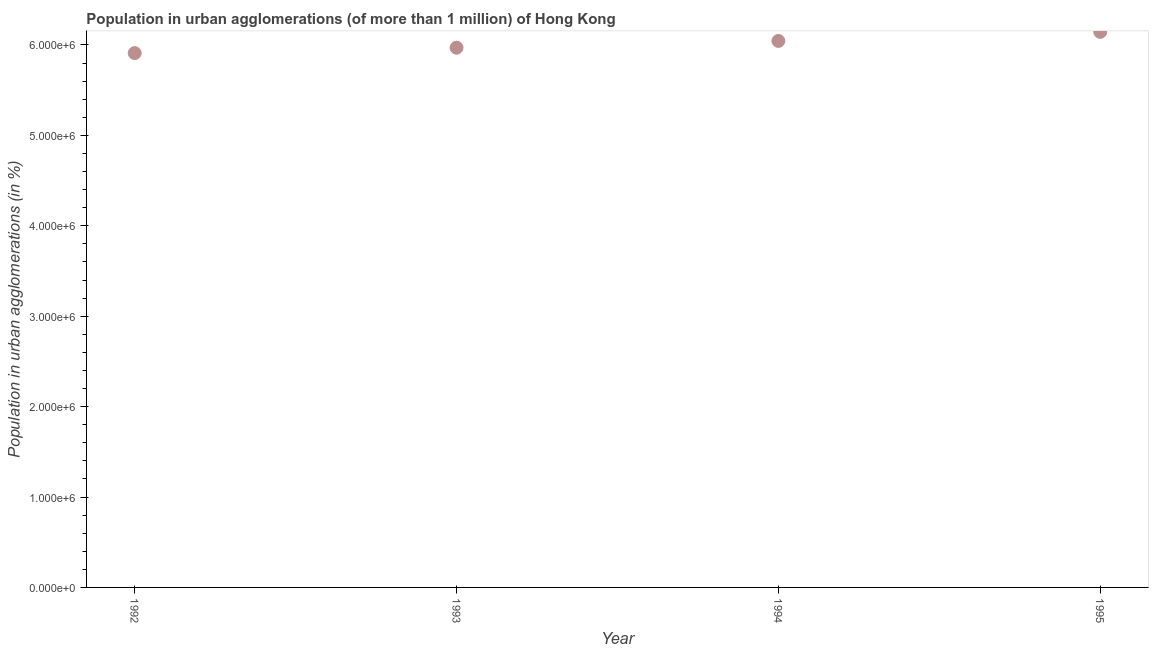What is the population in urban agglomerations in 1992?
Offer a terse response. 5.91e+06. Across all years, what is the maximum population in urban agglomerations?
Provide a short and direct response. 6.14e+06. Across all years, what is the minimum population in urban agglomerations?
Make the answer very short. 5.91e+06. In which year was the population in urban agglomerations minimum?
Offer a very short reply. 1992. What is the sum of the population in urban agglomerations?
Provide a short and direct response. 2.41e+07. What is the difference between the population in urban agglomerations in 1992 and 1993?
Make the answer very short. -5.96e+04. What is the average population in urban agglomerations per year?
Your answer should be compact. 6.02e+06. What is the median population in urban agglomerations?
Provide a succinct answer. 6.01e+06. What is the ratio of the population in urban agglomerations in 1993 to that in 1995?
Give a very brief answer. 0.97. Is the difference between the population in urban agglomerations in 1992 and 1995 greater than the difference between any two years?
Provide a short and direct response. Yes. What is the difference between the highest and the second highest population in urban agglomerations?
Offer a very short reply. 1.00e+05. Is the sum of the population in urban agglomerations in 1992 and 1995 greater than the maximum population in urban agglomerations across all years?
Offer a terse response. Yes. What is the difference between the highest and the lowest population in urban agglomerations?
Provide a short and direct response. 2.35e+05. What is the difference between two consecutive major ticks on the Y-axis?
Provide a succinct answer. 1.00e+06. What is the title of the graph?
Keep it short and to the point. Population in urban agglomerations (of more than 1 million) of Hong Kong. What is the label or title of the Y-axis?
Your response must be concise. Population in urban agglomerations (in %). What is the Population in urban agglomerations (in %) in 1992?
Your answer should be compact. 5.91e+06. What is the Population in urban agglomerations (in %) in 1993?
Offer a very short reply. 5.97e+06. What is the Population in urban agglomerations (in %) in 1994?
Offer a very short reply. 6.04e+06. What is the Population in urban agglomerations (in %) in 1995?
Your response must be concise. 6.14e+06. What is the difference between the Population in urban agglomerations (in %) in 1992 and 1993?
Provide a succinct answer. -5.96e+04. What is the difference between the Population in urban agglomerations (in %) in 1992 and 1994?
Your answer should be compact. -1.35e+05. What is the difference between the Population in urban agglomerations (in %) in 1992 and 1995?
Keep it short and to the point. -2.35e+05. What is the difference between the Population in urban agglomerations (in %) in 1993 and 1994?
Give a very brief answer. -7.50e+04. What is the difference between the Population in urban agglomerations (in %) in 1993 and 1995?
Provide a short and direct response. -1.75e+05. What is the difference between the Population in urban agglomerations (in %) in 1994 and 1995?
Offer a terse response. -1.00e+05. What is the ratio of the Population in urban agglomerations (in %) in 1992 to that in 1993?
Offer a terse response. 0.99. What is the ratio of the Population in urban agglomerations (in %) in 1992 to that in 1994?
Keep it short and to the point. 0.98. What is the ratio of the Population in urban agglomerations (in %) in 1992 to that in 1995?
Offer a terse response. 0.96. What is the ratio of the Population in urban agglomerations (in %) in 1993 to that in 1994?
Provide a short and direct response. 0.99. What is the ratio of the Population in urban agglomerations (in %) in 1993 to that in 1995?
Offer a terse response. 0.97. 